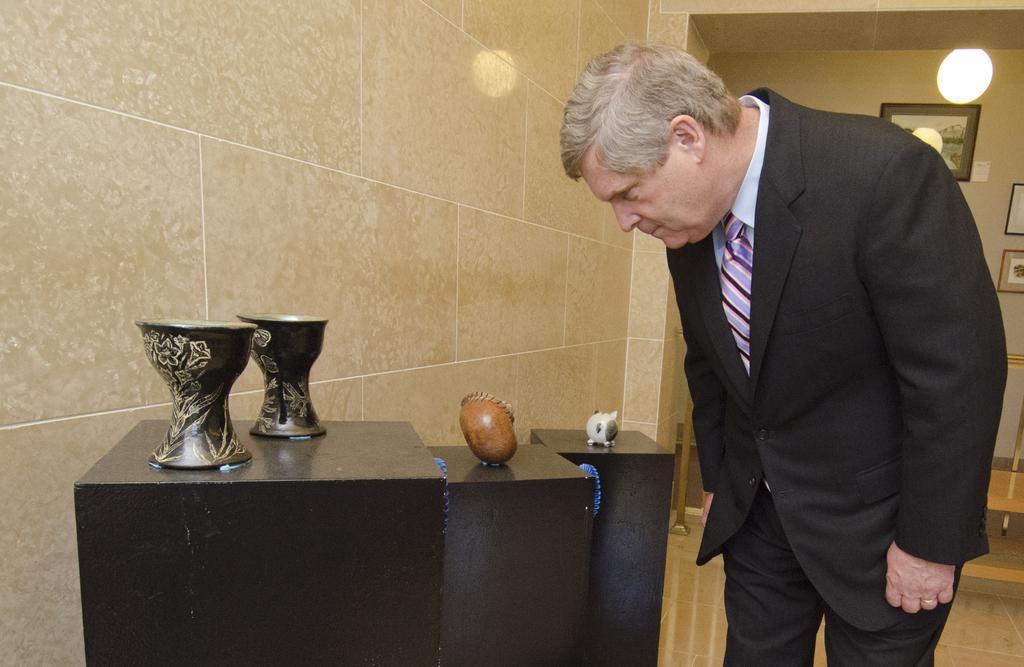Please provide a concise description of this image. In this picture, there is a man towards the right. He is wearing a black blazer and black trousers. Before him, there are three tables. On every table, there are some objects. On the top left, there is a wall with tiles. On the top right, there is wall with frames. 